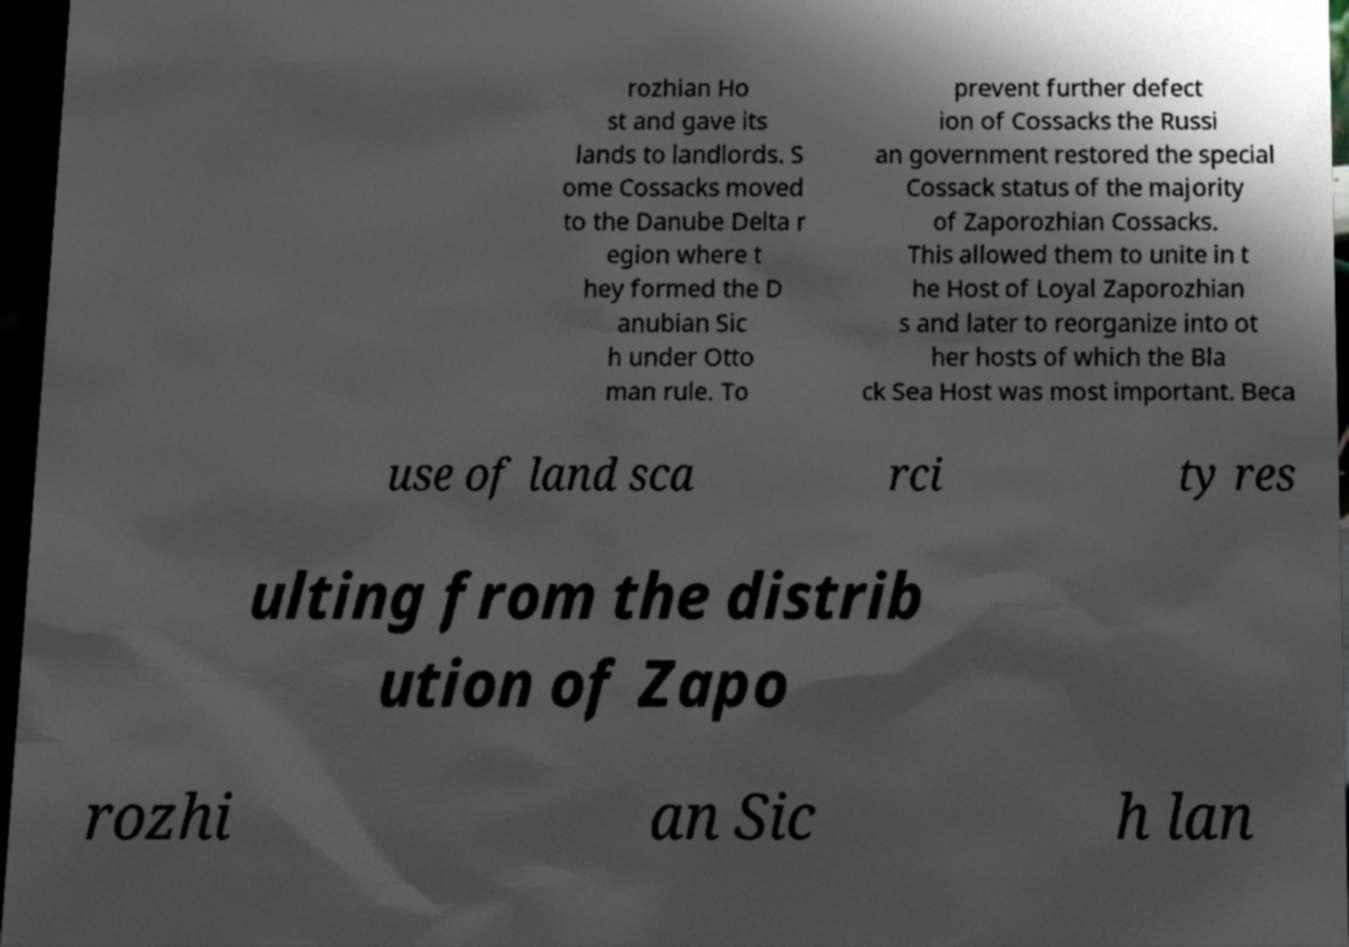Can you accurately transcribe the text from the provided image for me? rozhian Ho st and gave its lands to landlords. S ome Cossacks moved to the Danube Delta r egion where t hey formed the D anubian Sic h under Otto man rule. To prevent further defect ion of Cossacks the Russi an government restored the special Cossack status of the majority of Zaporozhian Cossacks. This allowed them to unite in t he Host of Loyal Zaporozhian s and later to reorganize into ot her hosts of which the Bla ck Sea Host was most important. Beca use of land sca rci ty res ulting from the distrib ution of Zapo rozhi an Sic h lan 